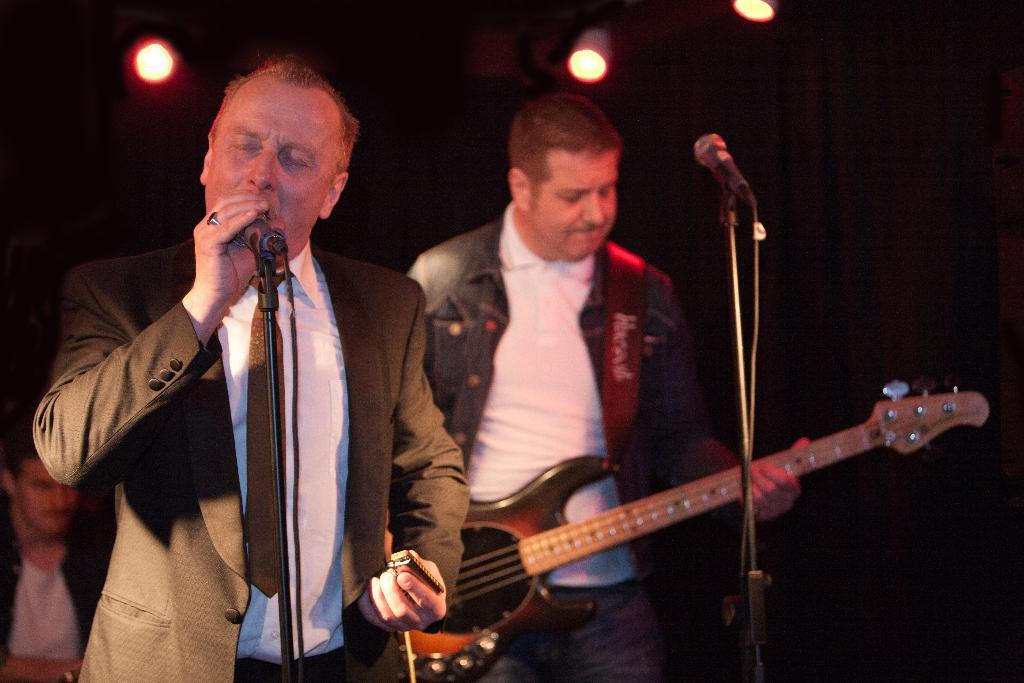What is the man in the image doing? The man is standing and singing in the image. What is the man holding while singing? The man is holding a microphone. Are there any other musicians in the image? Yes, there is another man standing and playing a guitar in the image. Can you describe the person in the background? There is a person in the background of the image, but no specific details are provided. What type of soup is being served in the image? There is no soup present in the image; it features a man singing and another playing a guitar. 